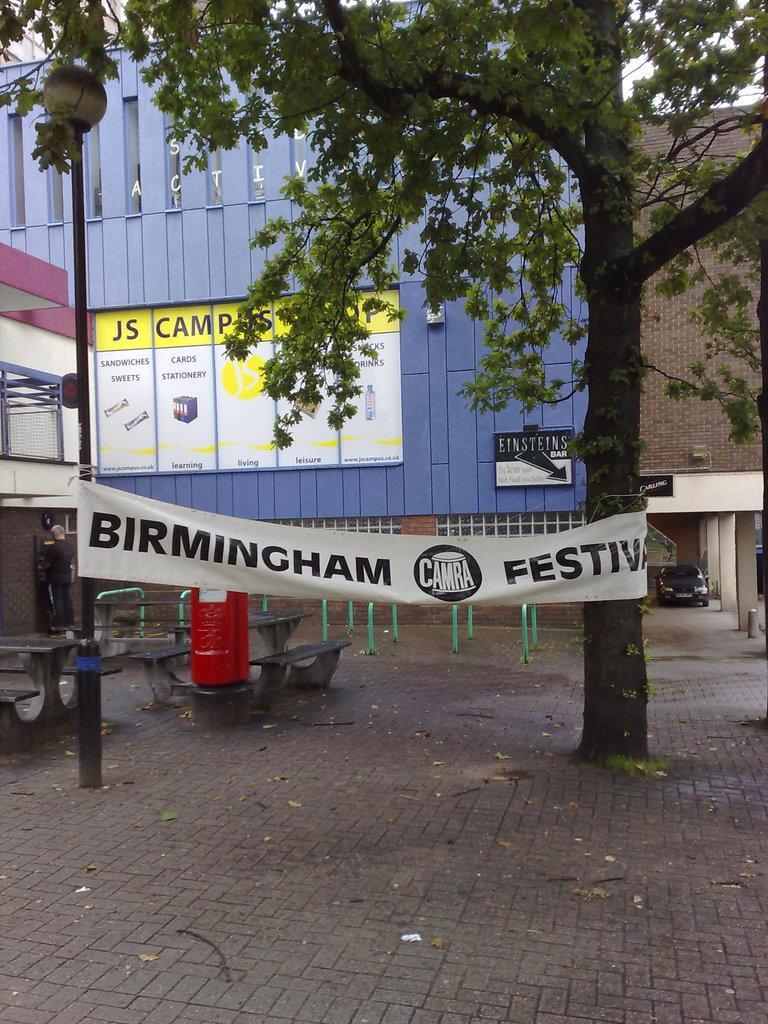Describe this image in one or two sentences. In this image we can see the buildings. On the building we can see a board and banner with text. In front of the building we can see a person, barriers and a red box. In the foreground we can see a banner attached to a tree and a pole. On the banner we can see the text. On the right side, we can see a car. 